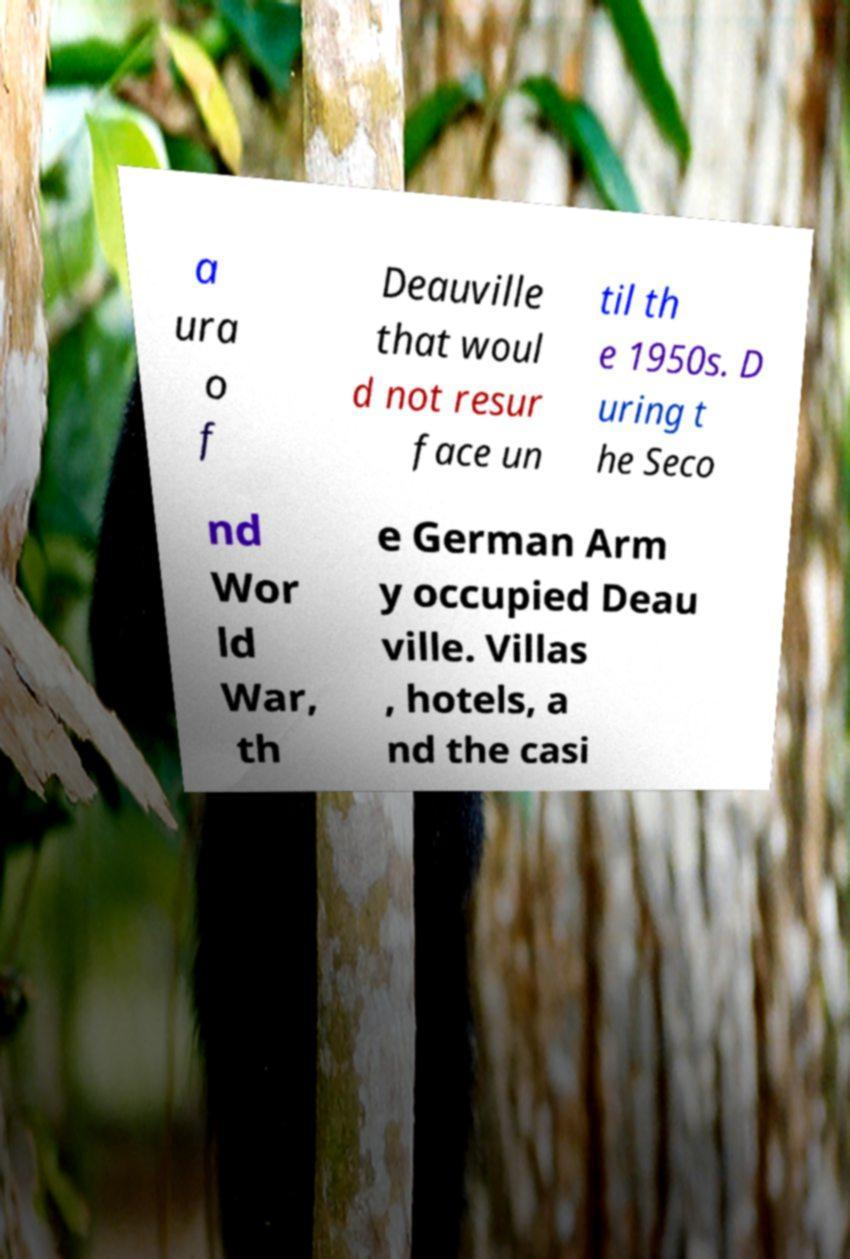What messages or text are displayed in this image? I need them in a readable, typed format. a ura o f Deauville that woul d not resur face un til th e 1950s. D uring t he Seco nd Wor ld War, th e German Arm y occupied Deau ville. Villas , hotels, a nd the casi 